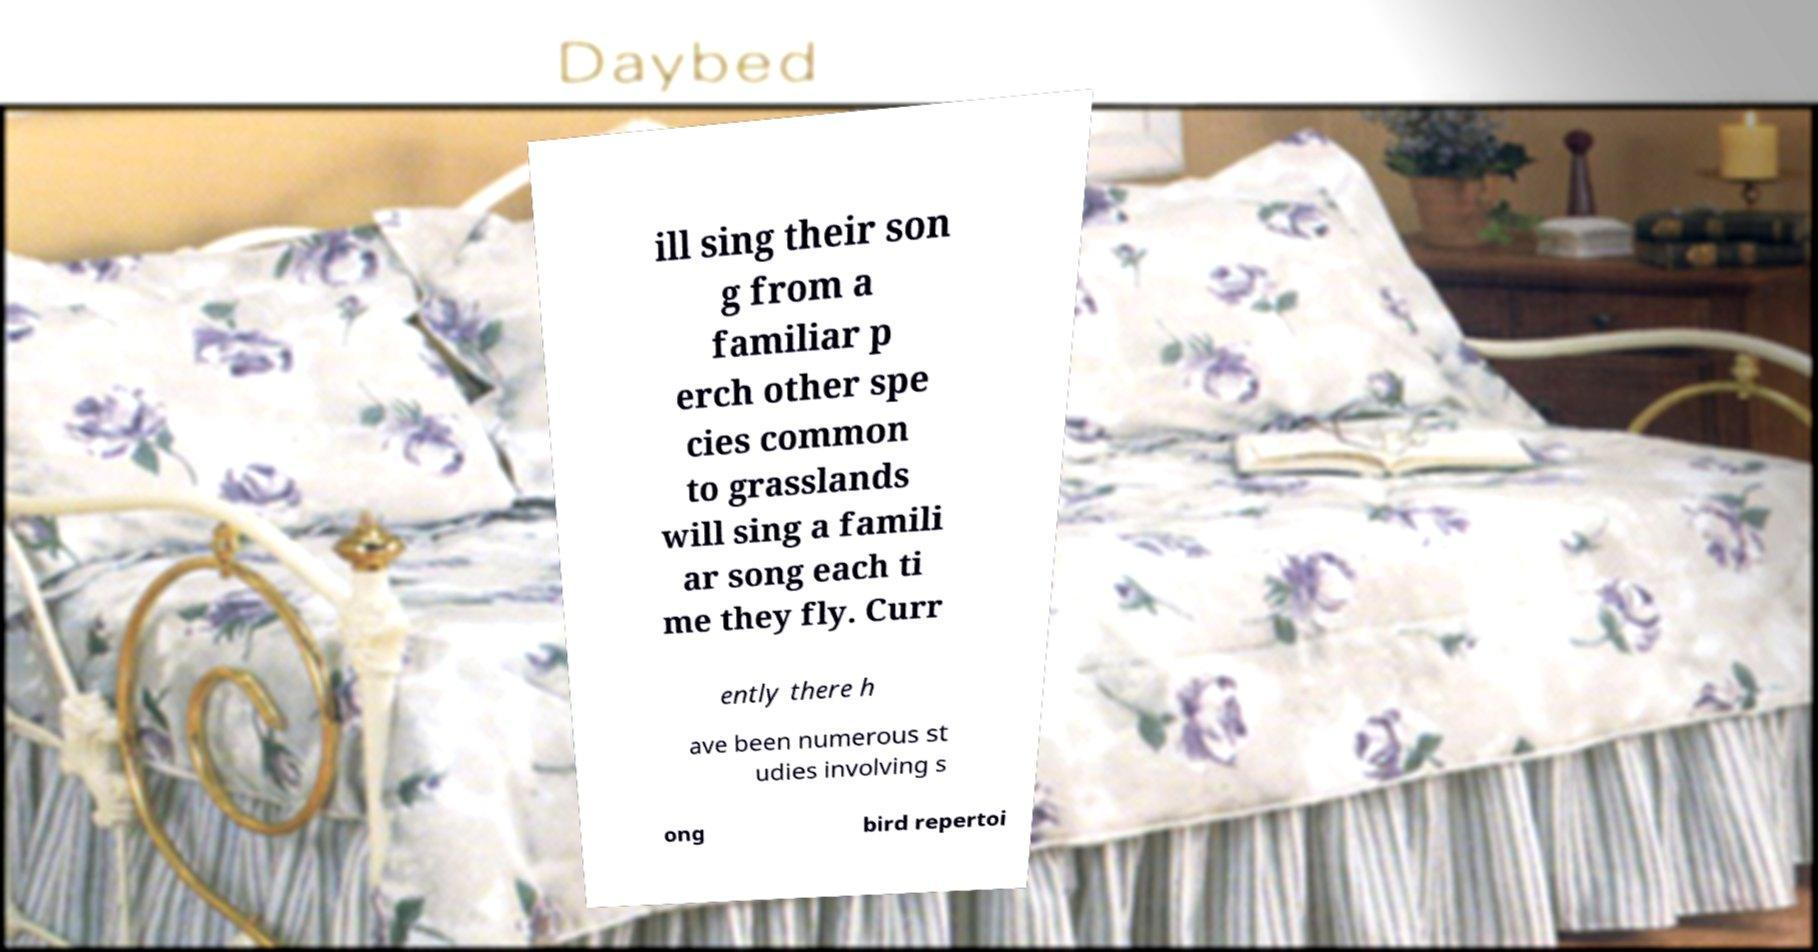Please read and relay the text visible in this image. What does it say? ill sing their son g from a familiar p erch other spe cies common to grasslands will sing a famili ar song each ti me they fly. Curr ently there h ave been numerous st udies involving s ong bird repertoi 